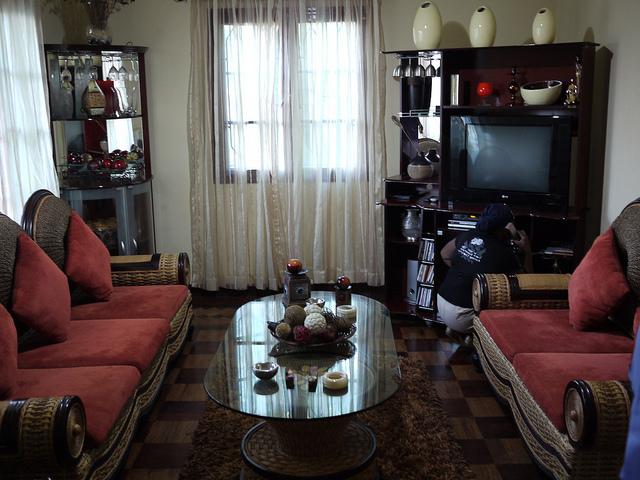Is it Christmas?
Keep it brief. No. Is this a minimalist room?
Answer briefly. No. What is the table made of?
Quick response, please. Glass. How many vases are on top of the entertainment center?
Be succinct. 3. 